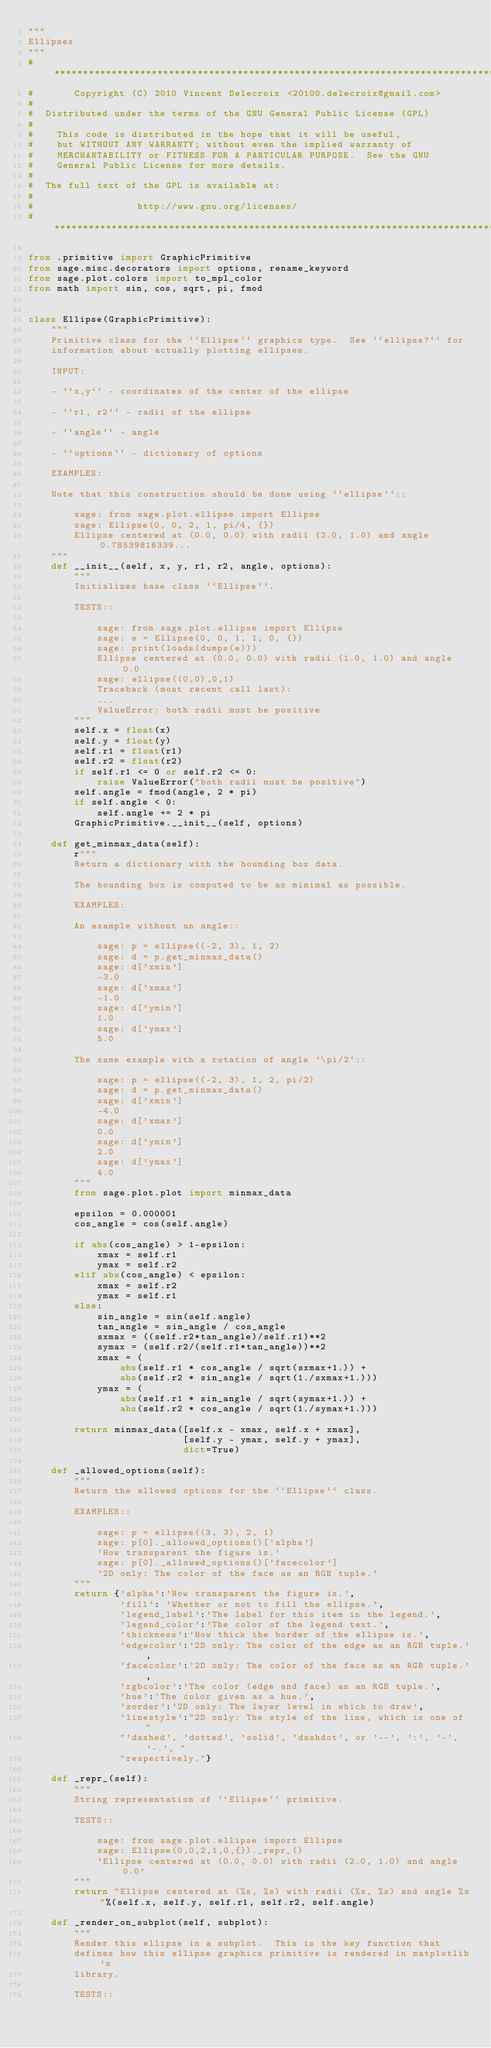Convert code to text. <code><loc_0><loc_0><loc_500><loc_500><_Python_>"""
Ellipses
"""
#*****************************************************************************
#       Copyright (C) 2010 Vincent Delecroix <20100.delecroix@gmail.com>
#
#  Distributed under the terms of the GNU General Public License (GPL)
#
#    This code is distributed in the hope that it will be useful,
#    but WITHOUT ANY WARRANTY; without even the implied warranty of
#    MERCHANTABILITY or FITNESS FOR A PARTICULAR PURPOSE.  See the GNU
#    General Public License for more details.
#
#  The full text of the GPL is available at:
#
#                  http://www.gnu.org/licenses/
#*****************************************************************************

from .primitive import GraphicPrimitive
from sage.misc.decorators import options, rename_keyword
from sage.plot.colors import to_mpl_color
from math import sin, cos, sqrt, pi, fmod


class Ellipse(GraphicPrimitive):
    """
    Primitive class for the ``Ellipse`` graphics type.  See ``ellipse?`` for
    information about actually plotting ellipses.

    INPUT:

    - ``x,y`` - coordinates of the center of the ellipse

    - ``r1, r2`` - radii of the ellipse

    - ``angle`` - angle

    - ``options`` - dictionary of options

    EXAMPLES:

    Note that this construction should be done using ``ellipse``::

        sage: from sage.plot.ellipse import Ellipse
        sage: Ellipse(0, 0, 2, 1, pi/4, {})
        Ellipse centered at (0.0, 0.0) with radii (2.0, 1.0) and angle 0.78539816339...
    """
    def __init__(self, x, y, r1, r2, angle, options):
        """
        Initializes base class ``Ellipse``.

        TESTS::

            sage: from sage.plot.ellipse import Ellipse
            sage: e = Ellipse(0, 0, 1, 1, 0, {})
            sage: print(loads(dumps(e)))
            Ellipse centered at (0.0, 0.0) with radii (1.0, 1.0) and angle 0.0
            sage: ellipse((0,0),0,1)
            Traceback (most recent call last):
            ...
            ValueError: both radii must be positive
        """
        self.x = float(x)
        self.y = float(y)
        self.r1 = float(r1)
        self.r2 = float(r2)
        if self.r1 <= 0 or self.r2 <= 0:
            raise ValueError("both radii must be positive")
        self.angle = fmod(angle, 2 * pi)
        if self.angle < 0:
            self.angle += 2 * pi
        GraphicPrimitive.__init__(self, options)

    def get_minmax_data(self):
        r"""
        Return a dictionary with the bounding box data.

        The bounding box is computed to be as minimal as possible.

        EXAMPLES:

        An example without an angle::

            sage: p = ellipse((-2, 3), 1, 2)
            sage: d = p.get_minmax_data()
            sage: d['xmin']
            -3.0
            sage: d['xmax']
            -1.0
            sage: d['ymin']
            1.0
            sage: d['ymax']
            5.0

        The same example with a rotation of angle `\pi/2`::

            sage: p = ellipse((-2, 3), 1, 2, pi/2)
            sage: d = p.get_minmax_data()
            sage: d['xmin']
            -4.0
            sage: d['xmax']
            0.0
            sage: d['ymin']
            2.0
            sage: d['ymax']
            4.0
        """
        from sage.plot.plot import minmax_data

        epsilon = 0.000001
        cos_angle = cos(self.angle)

        if abs(cos_angle) > 1-epsilon:
            xmax = self.r1
            ymax = self.r2
        elif abs(cos_angle) < epsilon:
            xmax = self.r2
            ymax = self.r1
        else:
            sin_angle = sin(self.angle)
            tan_angle = sin_angle / cos_angle
            sxmax = ((self.r2*tan_angle)/self.r1)**2
            symax = (self.r2/(self.r1*tan_angle))**2
            xmax = (
                abs(self.r1 * cos_angle / sqrt(sxmax+1.)) +
                abs(self.r2 * sin_angle / sqrt(1./sxmax+1.)))
            ymax = (
                abs(self.r1 * sin_angle / sqrt(symax+1.)) +
                abs(self.r2 * cos_angle / sqrt(1./symax+1.)))

        return minmax_data([self.x - xmax, self.x + xmax],
                           [self.y - ymax, self.y + ymax],
                           dict=True)

    def _allowed_options(self):
        """
        Return the allowed options for the ``Ellipse`` class.

        EXAMPLES::

            sage: p = ellipse((3, 3), 2, 1)
            sage: p[0]._allowed_options()['alpha']
            'How transparent the figure is.'
            sage: p[0]._allowed_options()['facecolor']
            '2D only: The color of the face as an RGB tuple.'
        """
        return {'alpha':'How transparent the figure is.',
                'fill': 'Whether or not to fill the ellipse.',
                'legend_label':'The label for this item in the legend.',
                'legend_color':'The color of the legend text.',
                'thickness':'How thick the border of the ellipse is.',
                'edgecolor':'2D only: The color of the edge as an RGB tuple.',
                'facecolor':'2D only: The color of the face as an RGB tuple.',
                'rgbcolor':'The color (edge and face) as an RGB tuple.',
                'hue':'The color given as a hue.',
                'zorder':'2D only: The layer level in which to draw',
                'linestyle':"2D only: The style of the line, which is one of "
                "'dashed', 'dotted', 'solid', 'dashdot', or '--', ':', '-', '-.', "
                "respectively."}

    def _repr_(self):
        """
        String representation of ``Ellipse`` primitive.

        TESTS::

            sage: from sage.plot.ellipse import Ellipse
            sage: Ellipse(0,0,2,1,0,{})._repr_()
            'Ellipse centered at (0.0, 0.0) with radii (2.0, 1.0) and angle 0.0'
        """
        return "Ellipse centered at (%s, %s) with radii (%s, %s) and angle %s"%(self.x, self.y, self.r1, self.r2, self.angle)

    def _render_on_subplot(self, subplot):
        """
        Render this ellipse in a subplot.  This is the key function that
        defines how this ellipse graphics primitive is rendered in matplotlib's
        library.

        TESTS::
</code> 